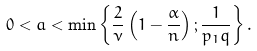Convert formula to latex. <formula><loc_0><loc_0><loc_500><loc_500>0 < a < \min \left \{ \frac { 2 } { \nu } \left ( 1 - \frac { \alpha } { n } \right ) ; \frac { 1 } { p _ { 1 } q } \right \} .</formula> 